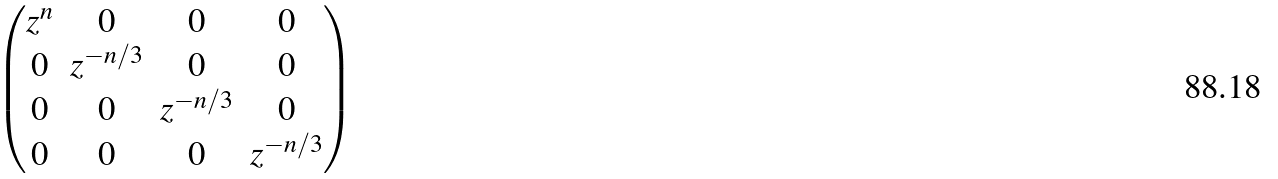<formula> <loc_0><loc_0><loc_500><loc_500>\begin{pmatrix} z ^ { n } & 0 & 0 & 0 \\ 0 & z ^ { - n / 3 } & 0 & 0 \\ 0 & 0 & z ^ { - n / 3 } & 0 \\ 0 & 0 & 0 & z ^ { - n / 3 } \end{pmatrix}</formula> 